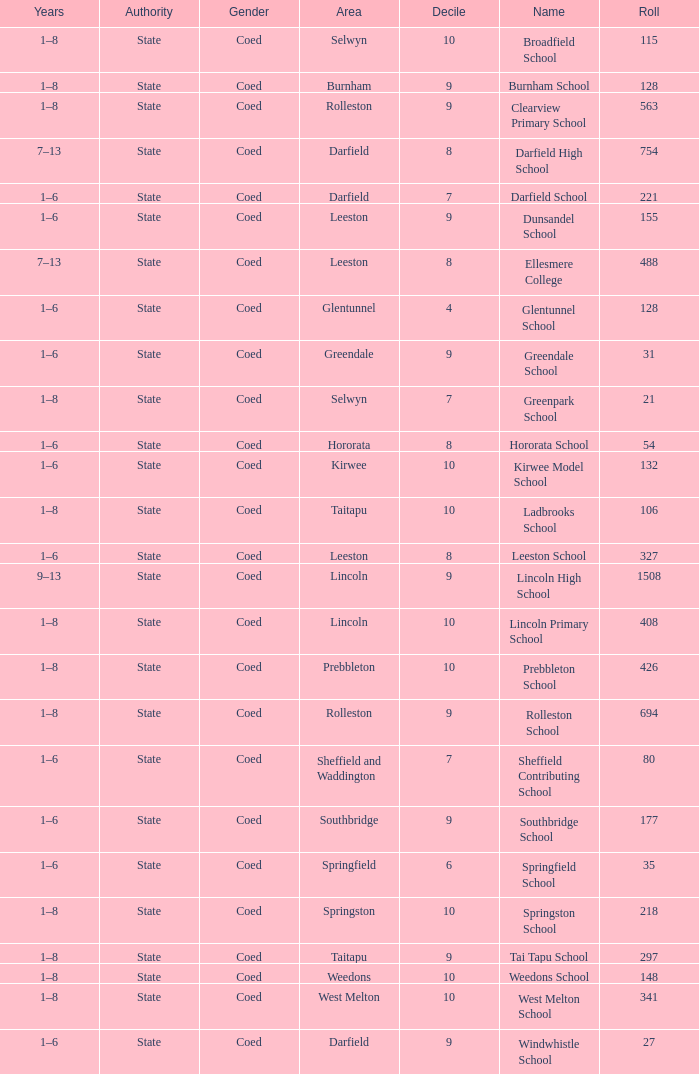Which area has a Decile of 9, and a Roll of 31? Greendale. 